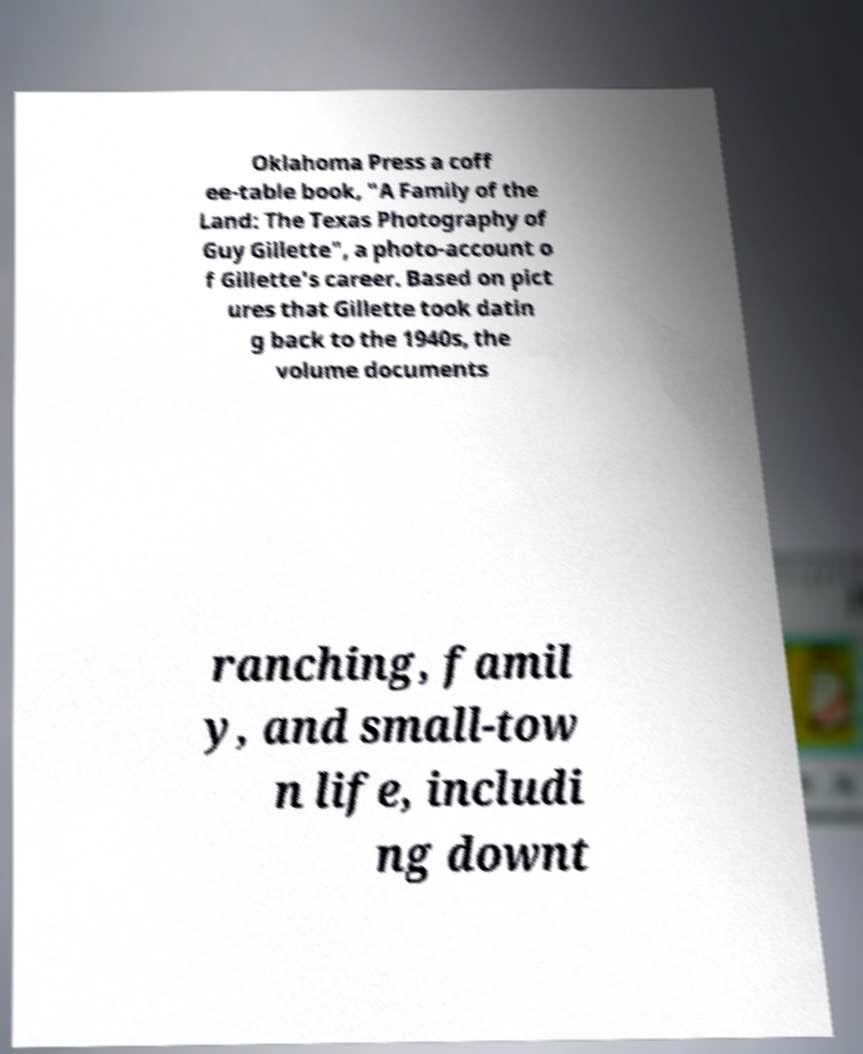Please identify and transcribe the text found in this image. Oklahoma Press a coff ee-table book, "A Family of the Land: The Texas Photography of Guy Gillette", a photo-account o f Gillette's career. Based on pict ures that Gillette took datin g back to the 1940s, the volume documents ranching, famil y, and small-tow n life, includi ng downt 